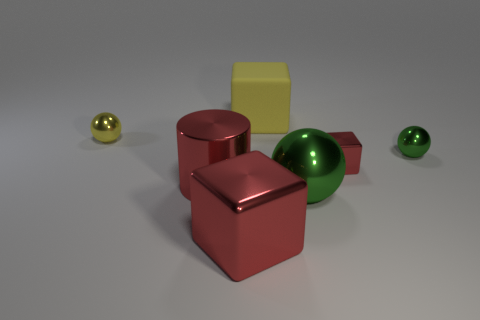Are there any other things that have the same material as the large yellow cube?
Provide a succinct answer. No. Is the cylinder the same color as the tiny block?
Provide a succinct answer. Yes. How many objects are either tiny purple metal spheres or red blocks?
Keep it short and to the point. 2. What size is the ball that is both on the left side of the small green metallic ball and behind the shiny cylinder?
Make the answer very short. Small. How many yellow spheres are the same material as the yellow block?
Provide a short and direct response. 0. There is a large ball that is the same material as the red cylinder; what color is it?
Keep it short and to the point. Green. Do the sphere to the left of the red cylinder and the big rubber object have the same color?
Make the answer very short. Yes. There is a red thing right of the large red cube; what is it made of?
Provide a succinct answer. Metal. Are there the same number of red objects in front of the big green metallic thing and large red metallic cubes?
Offer a very short reply. Yes. What number of large blocks are the same color as the large cylinder?
Provide a succinct answer. 1. 